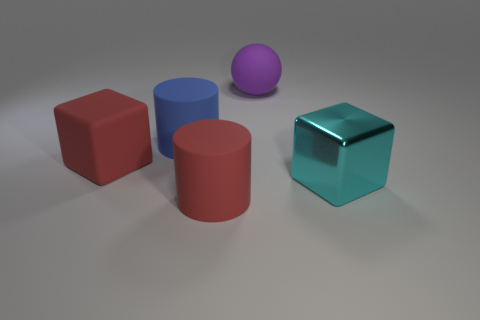The red thing behind the large cylinder that is to the right of the cylinder left of the large red matte cylinder is made of what material?
Give a very brief answer. Rubber. What is the material of the large cylinder that is the same color as the large matte cube?
Make the answer very short. Rubber. What number of objects are either purple spheres or large cyan metal objects?
Offer a terse response. 2. Do the large red object to the right of the big blue rubber cylinder and the cyan object have the same material?
Provide a short and direct response. No. What number of objects are cubes on the left side of the purple sphere or big matte spheres?
Give a very brief answer. 2. There is another cylinder that is the same material as the large blue cylinder; what color is it?
Your answer should be compact. Red. Are there any blocks of the same size as the purple sphere?
Give a very brief answer. Yes. Does the object right of the ball have the same color as the rubber cube?
Offer a very short reply. No. There is a large rubber thing that is both behind the large cyan object and in front of the large blue matte cylinder; what color is it?
Your response must be concise. Red. The blue object that is the same size as the cyan metallic thing is what shape?
Offer a very short reply. Cylinder. 